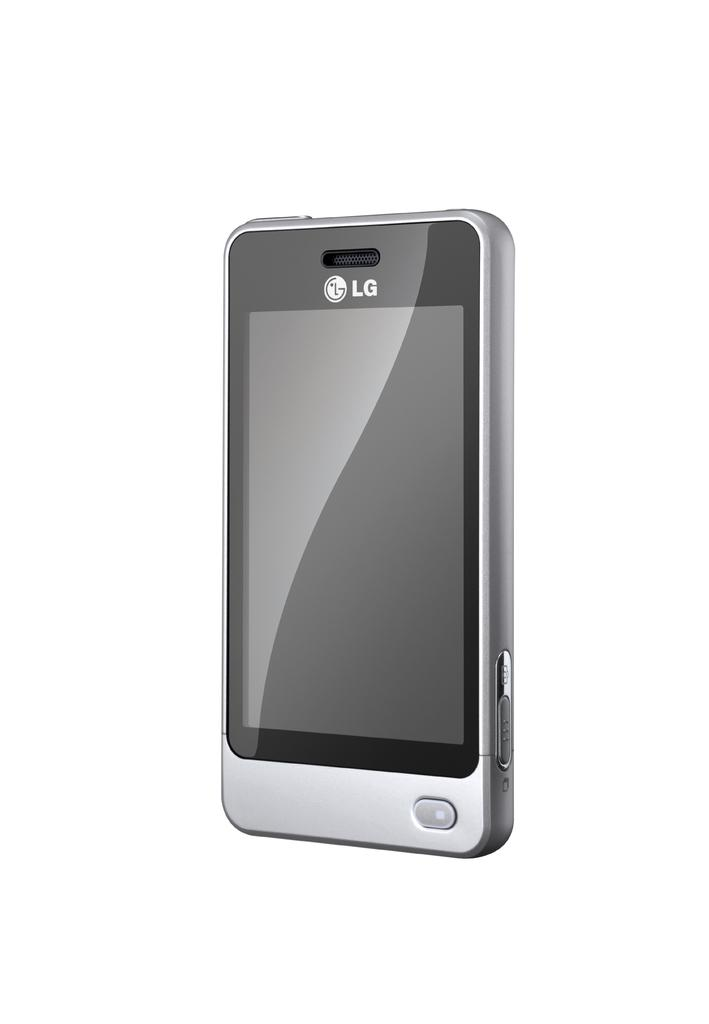<image>
Render a clear and concise summary of the photo. A silver and black LG branded phone which is currently turned off. 